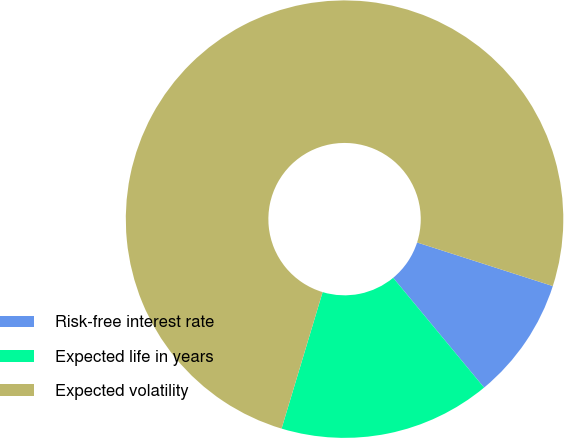Convert chart. <chart><loc_0><loc_0><loc_500><loc_500><pie_chart><fcel>Risk-free interest rate<fcel>Expected life in years<fcel>Expected volatility<nl><fcel>9.04%<fcel>15.66%<fcel>75.3%<nl></chart> 